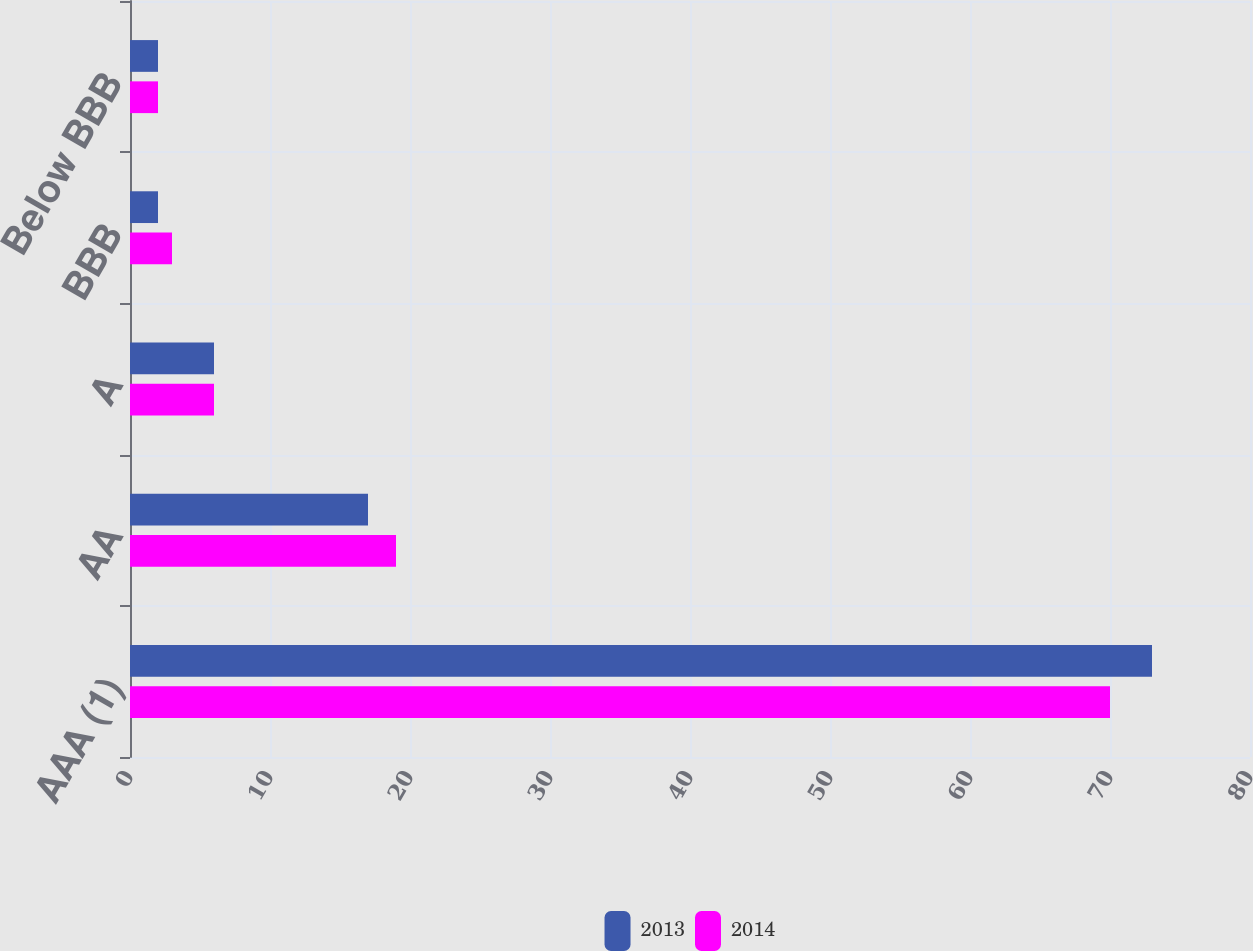Convert chart. <chart><loc_0><loc_0><loc_500><loc_500><stacked_bar_chart><ecel><fcel>AAA (1)<fcel>AA<fcel>A<fcel>BBB<fcel>Below BBB<nl><fcel>2013<fcel>73<fcel>17<fcel>6<fcel>2<fcel>2<nl><fcel>2014<fcel>70<fcel>19<fcel>6<fcel>3<fcel>2<nl></chart> 